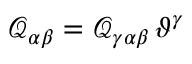<formula> <loc_0><loc_0><loc_500><loc_500>\mathcal { Q } _ { \alpha \beta } = \mathcal { Q } _ { \gamma \alpha \beta } \, \vartheta ^ { \gamma }</formula> 